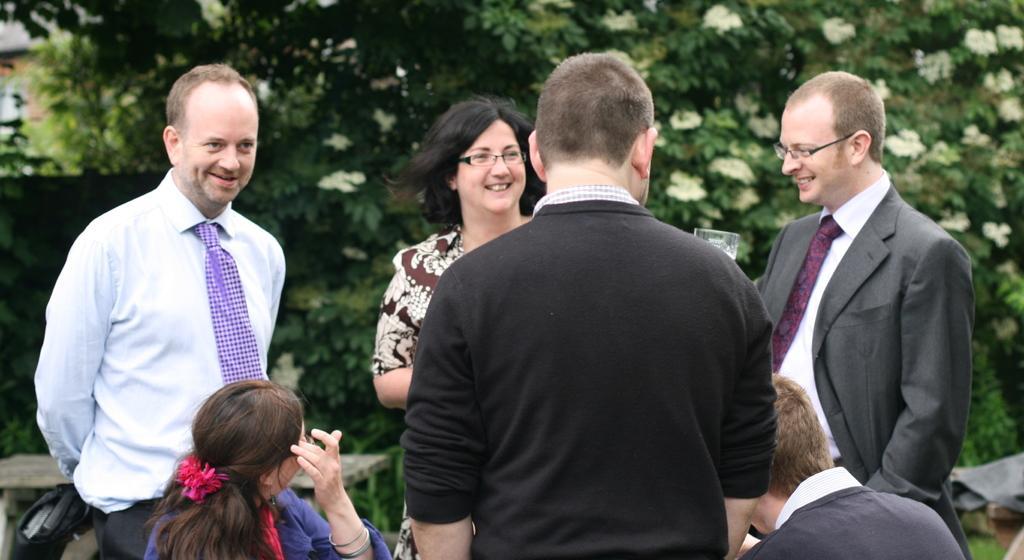How would you summarize this image in a sentence or two? In this picture, we see four people are standing. The woman in blue T-shirt and the man in black T-shirt are sitting. The man in a white shirt and black blazer who is wearing spectacles is smiling. The man in the white shirt is standing. He is smiling. Behind him, we see a wooden table. In the background, there are trees. 